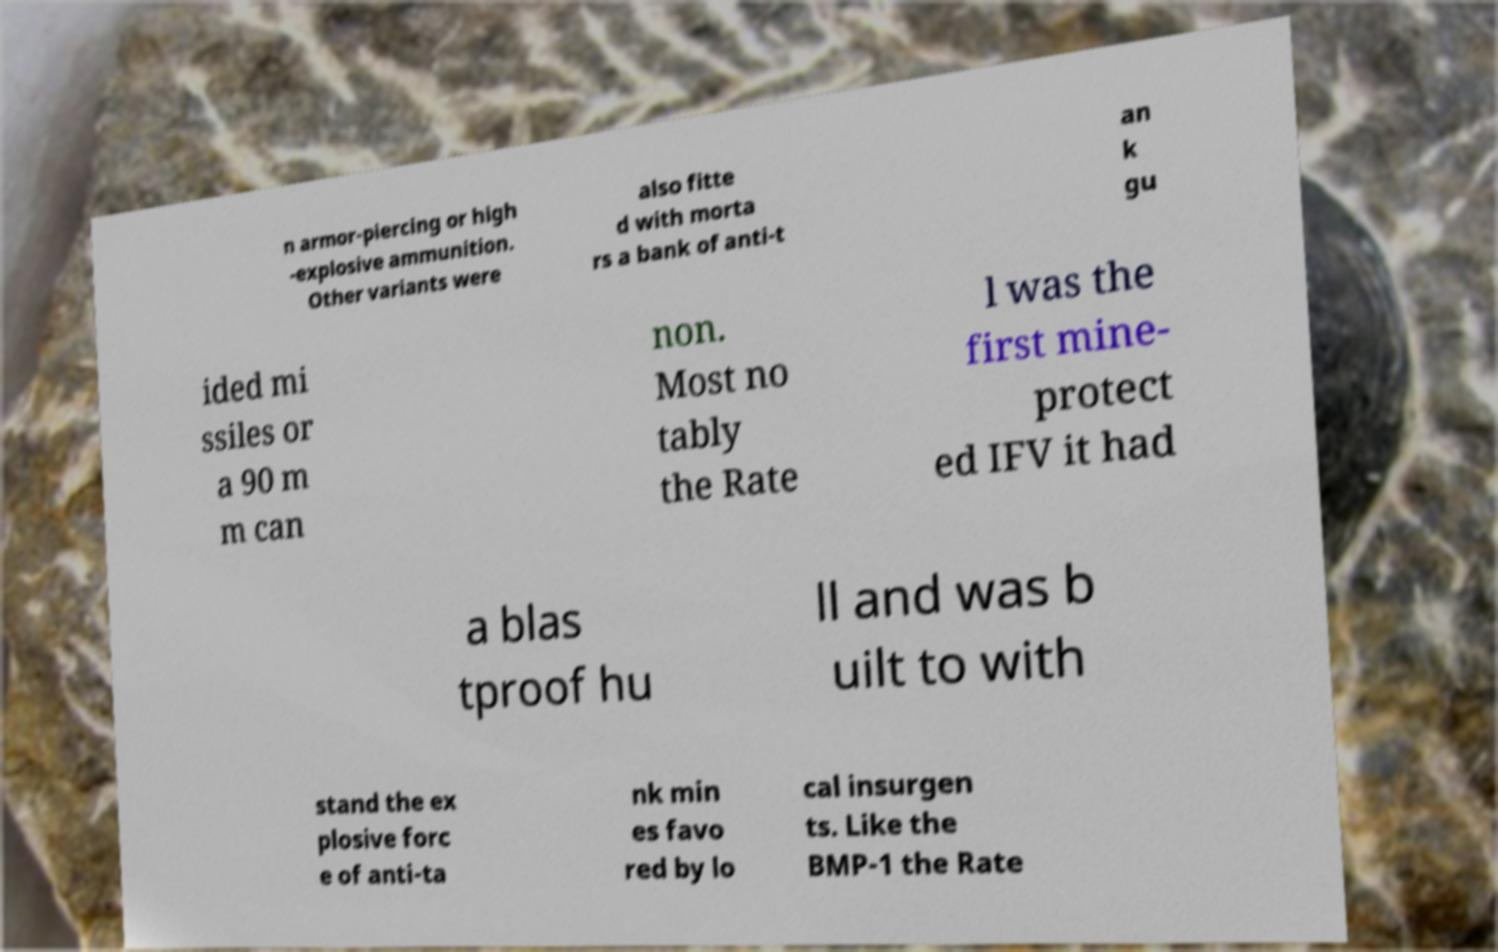Please read and relay the text visible in this image. What does it say? n armor-piercing or high -explosive ammunition. Other variants were also fitte d with morta rs a bank of anti-t an k gu ided mi ssiles or a 90 m m can non. Most no tably the Rate l was the first mine- protect ed IFV it had a blas tproof hu ll and was b uilt to with stand the ex plosive forc e of anti-ta nk min es favo red by lo cal insurgen ts. Like the BMP-1 the Rate 